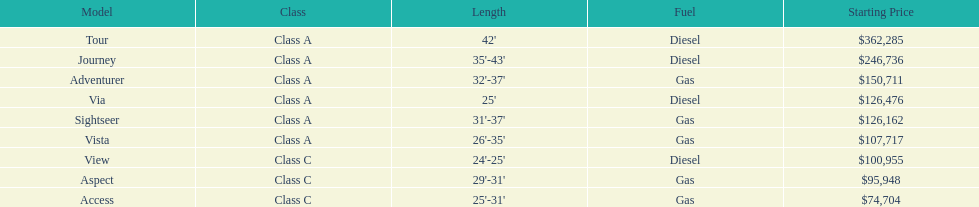How long is the aspect? 29'-31'. 